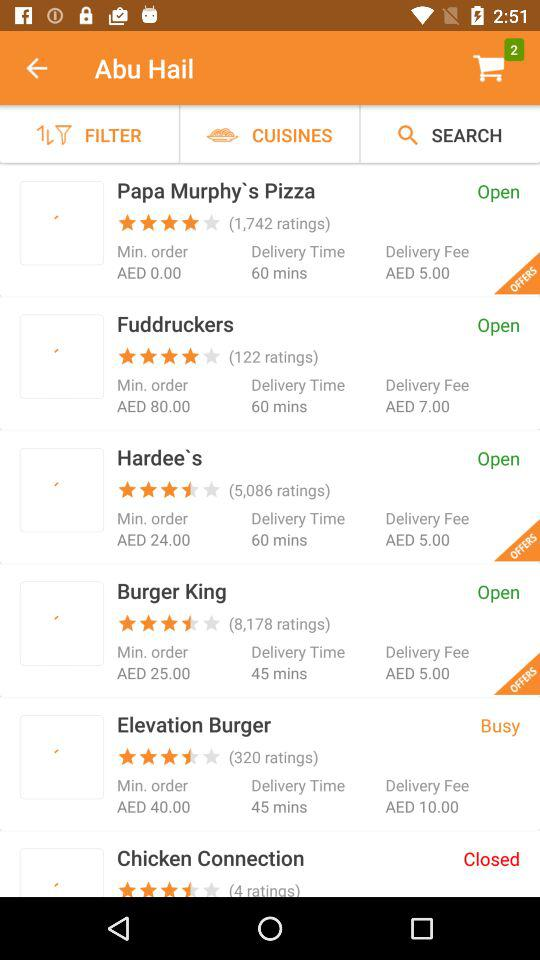How many items in total are in the cart? There are 2 items in the cart. 